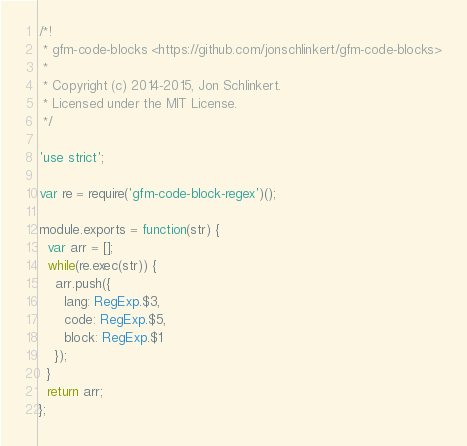Convert code to text. <code><loc_0><loc_0><loc_500><loc_500><_JavaScript_>/*!
 * gfm-code-blocks <https://github.com/jonschlinkert/gfm-code-blocks>
 *
 * Copyright (c) 2014-2015, Jon Schlinkert.
 * Licensed under the MIT License.
 */

'use strict';

var re = require('gfm-code-block-regex')();

module.exports = function(str) {
  var arr = [];
  while(re.exec(str)) {
    arr.push({
      lang: RegExp.$3,
      code: RegExp.$5,
      block: RegExp.$1
    });
  }
  return arr;
};
</code> 